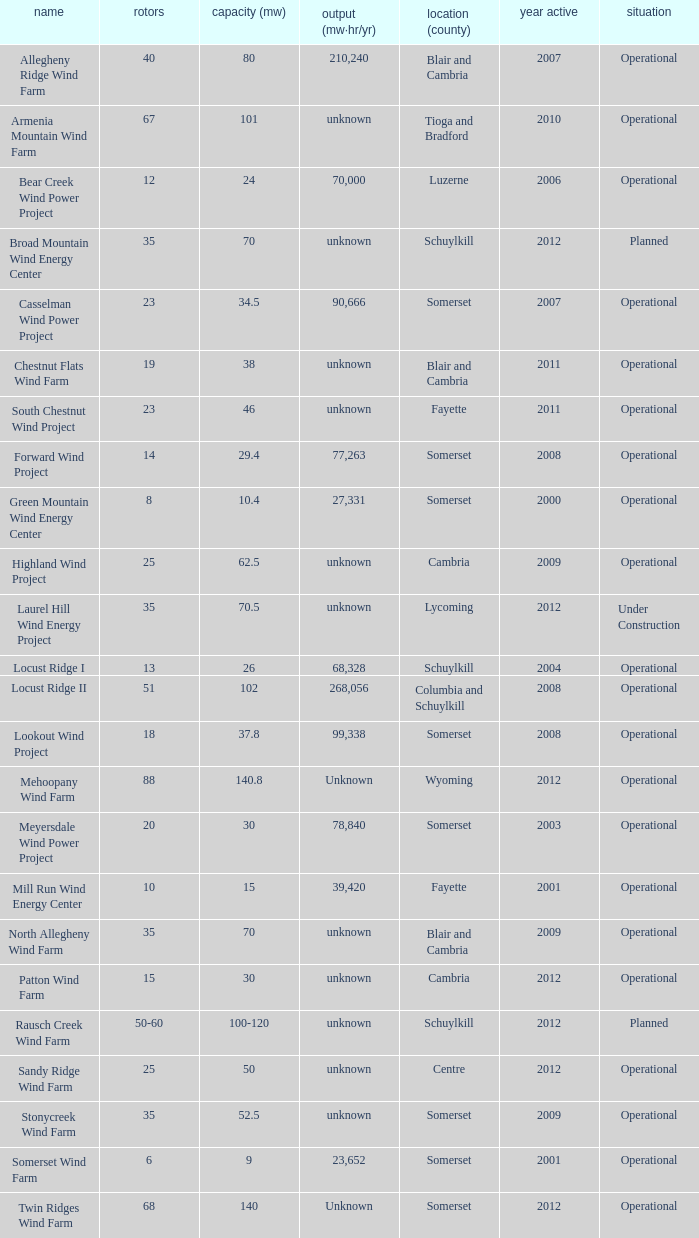What locations are considered centre? Unknown. Give me the full table as a dictionary. {'header': ['name', 'rotors', 'capacity (mw)', 'output (mw·hr/yr)', 'location (county)', 'year active', 'situation'], 'rows': [['Allegheny Ridge Wind Farm', '40', '80', '210,240', 'Blair and Cambria', '2007', 'Operational'], ['Armenia Mountain Wind Farm', '67', '101', 'unknown', 'Tioga and Bradford', '2010', 'Operational'], ['Bear Creek Wind Power Project', '12', '24', '70,000', 'Luzerne', '2006', 'Operational'], ['Broad Mountain Wind Energy Center', '35', '70', 'unknown', 'Schuylkill', '2012', 'Planned'], ['Casselman Wind Power Project', '23', '34.5', '90,666', 'Somerset', '2007', 'Operational'], ['Chestnut Flats Wind Farm', '19', '38', 'unknown', 'Blair and Cambria', '2011', 'Operational'], ['South Chestnut Wind Project', '23', '46', 'unknown', 'Fayette', '2011', 'Operational'], ['Forward Wind Project', '14', '29.4', '77,263', 'Somerset', '2008', 'Operational'], ['Green Mountain Wind Energy Center', '8', '10.4', '27,331', 'Somerset', '2000', 'Operational'], ['Highland Wind Project', '25', '62.5', 'unknown', 'Cambria', '2009', 'Operational'], ['Laurel Hill Wind Energy Project', '35', '70.5', 'unknown', 'Lycoming', '2012', 'Under Construction'], ['Locust Ridge I', '13', '26', '68,328', 'Schuylkill', '2004', 'Operational'], ['Locust Ridge II', '51', '102', '268,056', 'Columbia and Schuylkill', '2008', 'Operational'], ['Lookout Wind Project', '18', '37.8', '99,338', 'Somerset', '2008', 'Operational'], ['Mehoopany Wind Farm', '88', '140.8', 'Unknown', 'Wyoming', '2012', 'Operational'], ['Meyersdale Wind Power Project', '20', '30', '78,840', 'Somerset', '2003', 'Operational'], ['Mill Run Wind Energy Center', '10', '15', '39,420', 'Fayette', '2001', 'Operational'], ['North Allegheny Wind Farm', '35', '70', 'unknown', 'Blair and Cambria', '2009', 'Operational'], ['Patton Wind Farm', '15', '30', 'unknown', 'Cambria', '2012', 'Operational'], ['Rausch Creek Wind Farm', '50-60', '100-120', 'unknown', 'Schuylkill', '2012', 'Planned'], ['Sandy Ridge Wind Farm', '25', '50', 'unknown', 'Centre', '2012', 'Operational'], ['Stonycreek Wind Farm', '35', '52.5', 'unknown', 'Somerset', '2009', 'Operational'], ['Somerset Wind Farm', '6', '9', '23,652', 'Somerset', '2001', 'Operational'], ['Twin Ridges Wind Farm', '68', '140', 'Unknown', 'Somerset', '2012', 'Operational']]} 